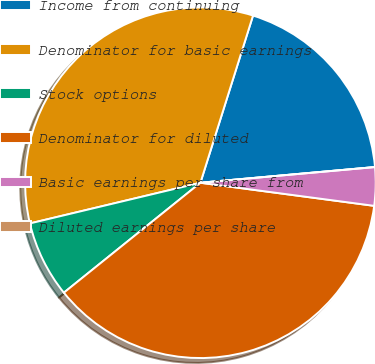<chart> <loc_0><loc_0><loc_500><loc_500><pie_chart><fcel>Income from continuing<fcel>Denominator for basic earnings<fcel>Stock options<fcel>Denominator for diluted<fcel>Basic earnings per share from<fcel>Diluted earnings per share<nl><fcel>18.72%<fcel>33.58%<fcel>7.06%<fcel>37.11%<fcel>3.53%<fcel>0.0%<nl></chart> 